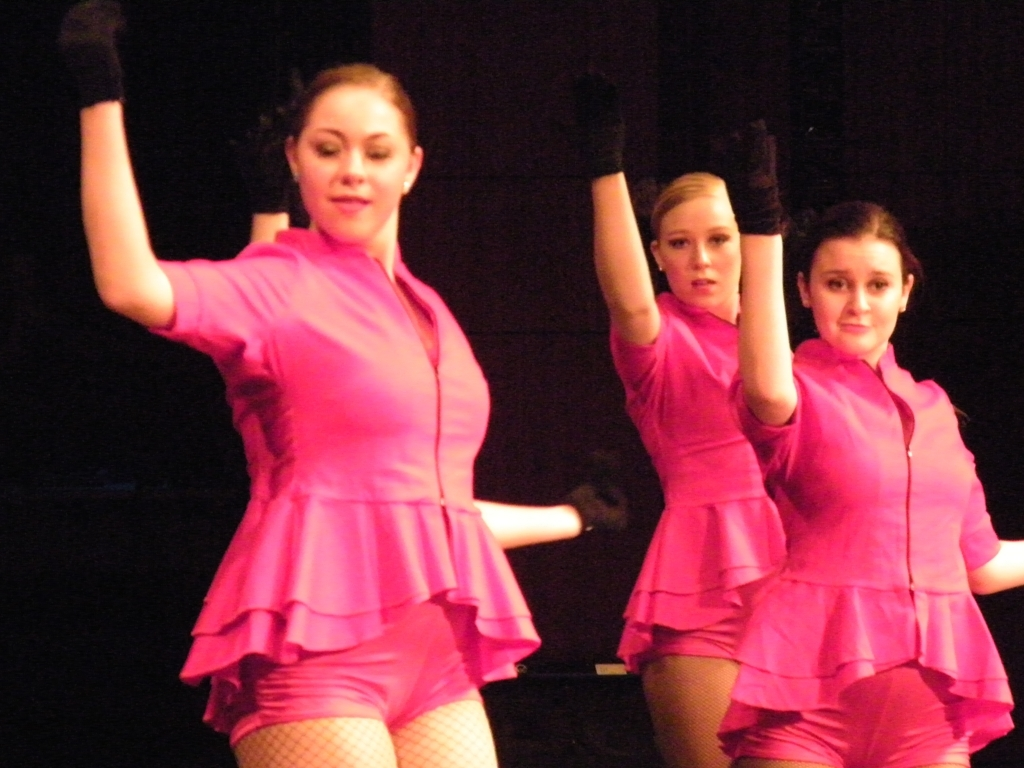Is the background too dark? While the background is moderately lit, providing a decent contrast for the performers, it could benefit from additional lighting to augment their visibility and bring more focus to their expressions and movements. 